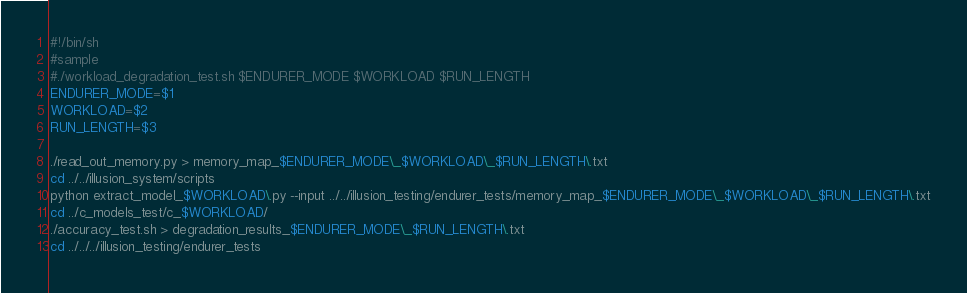Convert code to text. <code><loc_0><loc_0><loc_500><loc_500><_Bash_>#!/bin/sh
#sample
#./workload_degradation_test.sh $ENDURER_MODE $WORKLOAD $RUN_LENGTH
ENDURER_MODE=$1
WORKLOAD=$2
RUN_LENGTH=$3

./read_out_memory.py > memory_map_$ENDURER_MODE\_$WORKLOAD\_$RUN_LENGTH\.txt
cd ../../illusion_system/scripts
python extract_model_$WORKLOAD\.py --input ../../illusion_testing/endurer_tests/memory_map_$ENDURER_MODE\_$WORKLOAD\_$RUN_LENGTH\.txt
cd ../c_models_test/c_$WORKLOAD/
./accuracy_test.sh > degradation_results_$ENDURER_MODE\_$RUN_LENGTH\.txt
cd ../../../illusion_testing/endurer_tests

</code> 